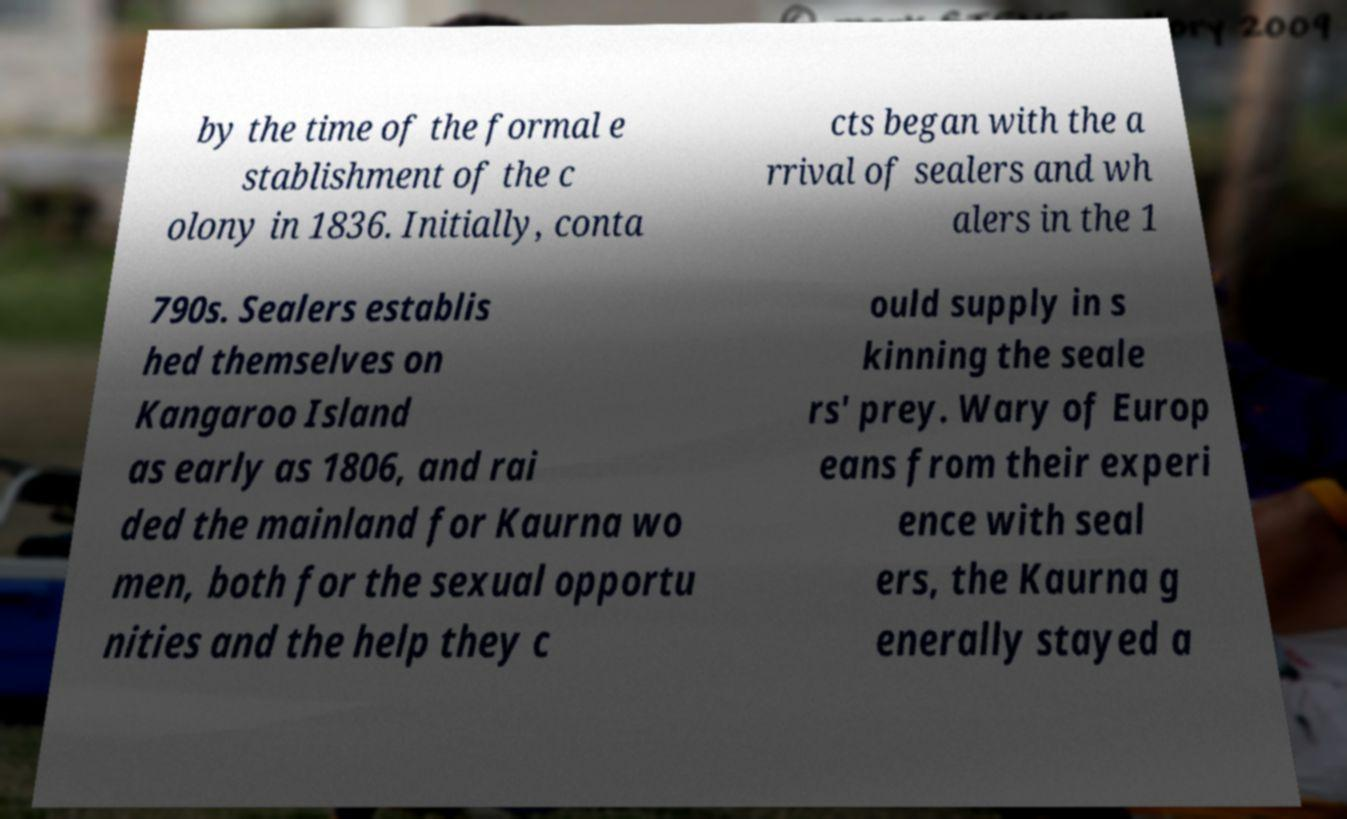Can you read and provide the text displayed in the image?This photo seems to have some interesting text. Can you extract and type it out for me? by the time of the formal e stablishment of the c olony in 1836. Initially, conta cts began with the a rrival of sealers and wh alers in the 1 790s. Sealers establis hed themselves on Kangaroo Island as early as 1806, and rai ded the mainland for Kaurna wo men, both for the sexual opportu nities and the help they c ould supply in s kinning the seale rs' prey. Wary of Europ eans from their experi ence with seal ers, the Kaurna g enerally stayed a 